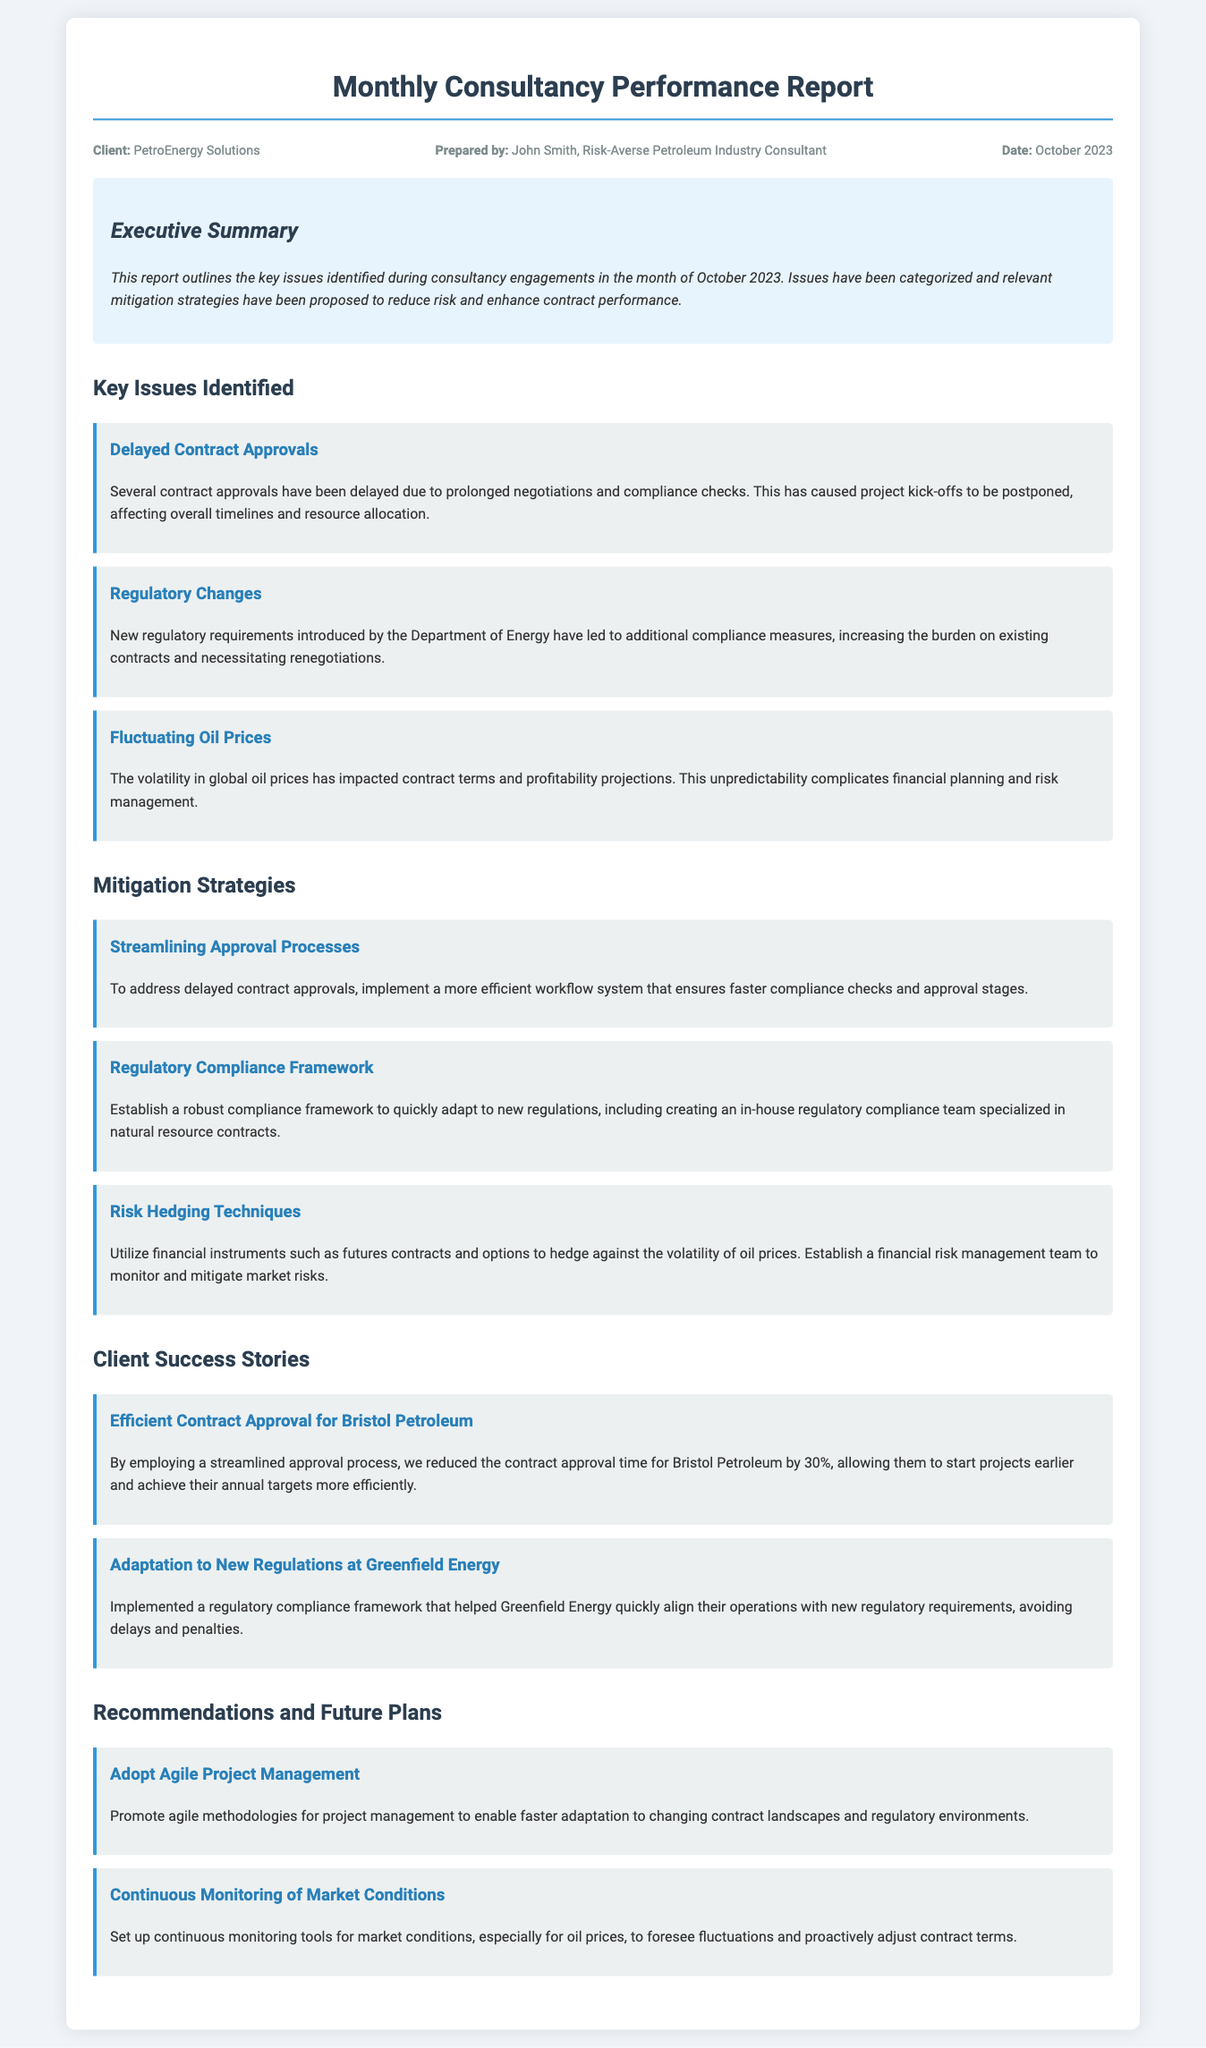What is the client name? The client's name is listed at the top of the report under "Client," which is "PetroEnergy Solutions."
Answer: PetroEnergy Solutions Who prepared the report? The "Prepared by" section identifies who prepared the report as "John Smith, Risk-Averse Petroleum Industry Consultant."
Answer: John Smith What is the date of the report? The report's date is provided in the header and is specified as "October 2023."
Answer: October 2023 What is one key issue identified? The document lists specific key issues, one of which is "Delayed Contract Approvals."
Answer: Delayed Contract Approvals What is a proposed mitigation strategy? The report suggests several strategies; one is "Streamlining Approval Processes."
Answer: Streamlining Approval Processes How much did Bristol Petroleum reduce their contract approval time? The report states that Bristol Petroleum's contract approval time was reduced by "30%."
Answer: 30% What was implemented for Greenfield Energy? The report notes that a "regulatory compliance framework" was implemented for Greenfield Energy.
Answer: Regulatory compliance framework What is a recommendation mentioned in the report? One of the recommendations made in the report is to "Adopt Agile Project Management."
Answer: Adopt Agile Project Management 